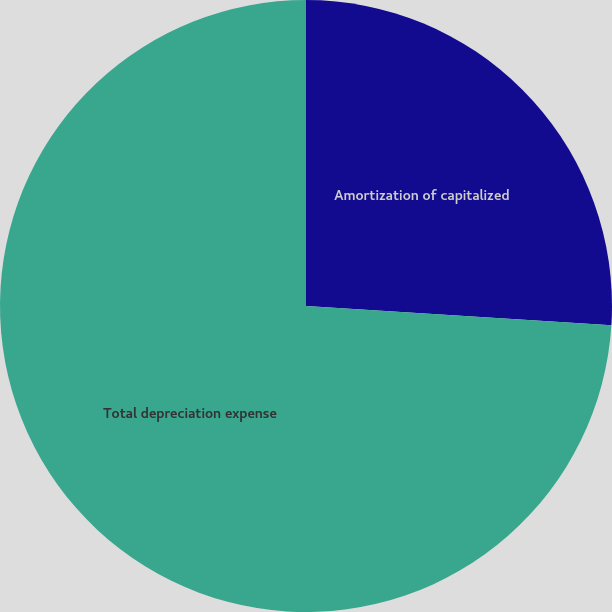Convert chart. <chart><loc_0><loc_0><loc_500><loc_500><pie_chart><fcel>Amortization of capitalized<fcel>Total depreciation expense<nl><fcel>26.0%<fcel>74.0%<nl></chart> 